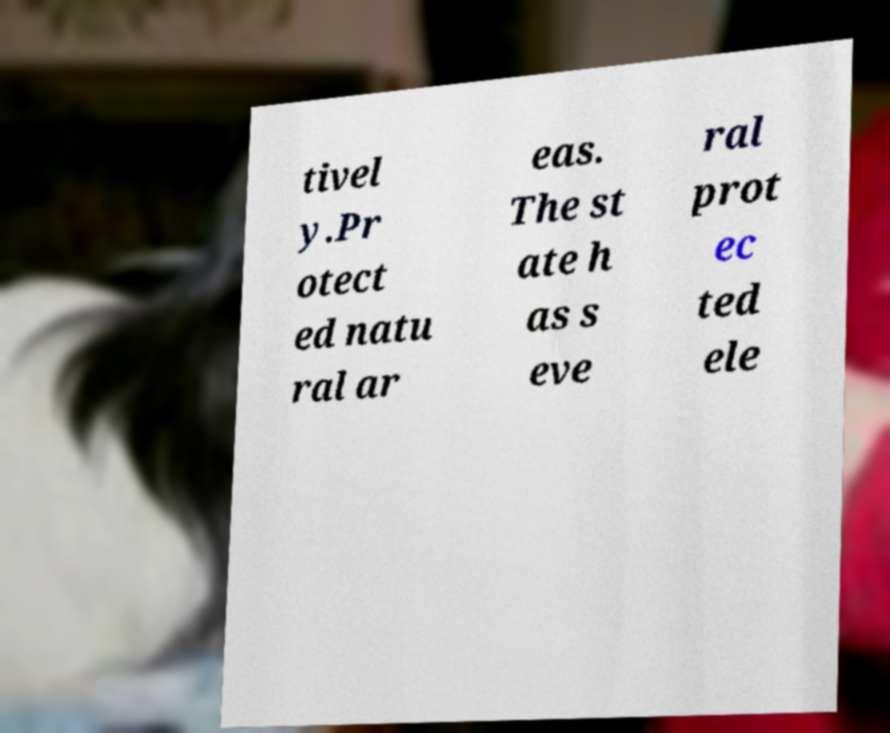There's text embedded in this image that I need extracted. Can you transcribe it verbatim? tivel y.Pr otect ed natu ral ar eas. The st ate h as s eve ral prot ec ted ele 